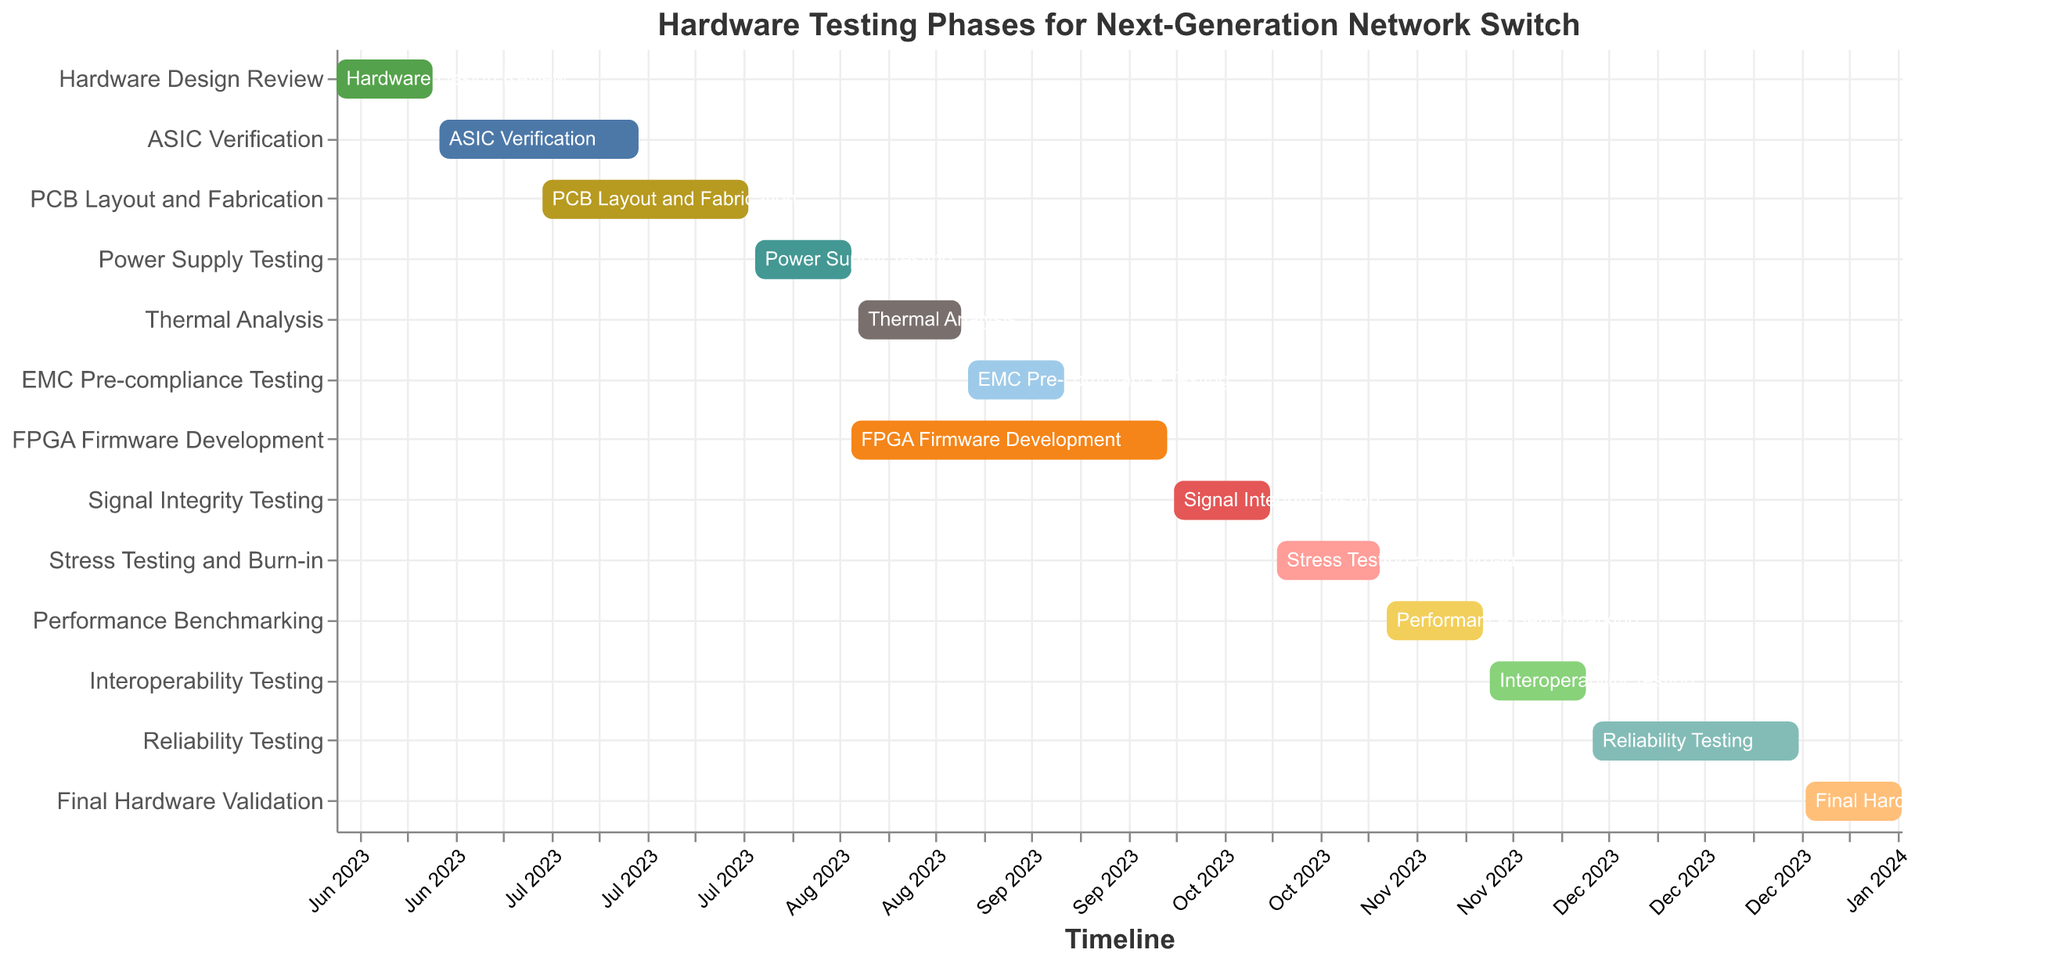What's the title of the figure? The title is located at the top of the Gantt Chart and provides a summary of what the chart represents.
Answer: Hardware Testing Phases for Next-Generation Network Switch Which task has the longest duration? To determine which task has the longest duration, compare the "Duration" field for each task listed. The task with the highest number is the longest.
Answer: FPGA Firmware Development When does the Power Supply Testing start and end? The start and end dates for each task are listed alongside their names. For Power Supply Testing, check these fields.
Answer: Start: 2023-08-01, End: 2023-08-15 How many tasks start in June 2023? Look for tasks with start dates in June 2023 by checking the "Start Date" field.
Answer: 2 tasks What is the total duration of tasks that end in August 2023? Identify tasks ending in August 2023 and sum their durations.
Answer: 75 days (14 for Power Supply Testing, 15 for Thermal Analysis, and 46 for FPGA Firmware Development) Do any tasks overlap in August 2023? If yes, which ones? To check for overlapping tasks in August 2023, identify tasks that have any portion of their duration covering the same dates in August.
Answer: Yes, Power Supply Testing, Thermal Analysis, and FPGA Firmware Development Which tasks are scheduled to end in October 2023? By checking the "End Date" for tasks ending in October 2023, you can identify these tasks.
Answer: Signal Integrity Testing, Stress Testing and Burn-in What is the duration between the start of Hardware Design Review and the end of Final Hardware Validation? Calculate the time between the "Start Date" of Hardware Design Review and the "End Date" of Final Hardware Validation.
Answer: 229 days Compare the duration of PCB Layout and Fabrication with Reliability Testing. Which one takes longer? Compare the "Duration" values for these two tasks.
Answer: PCB Layout and Fabrication How many tasks are scheduled to start after September 2023? Count the tasks with "Start Date" fields later than September 2023.
Answer: 5 tasks 